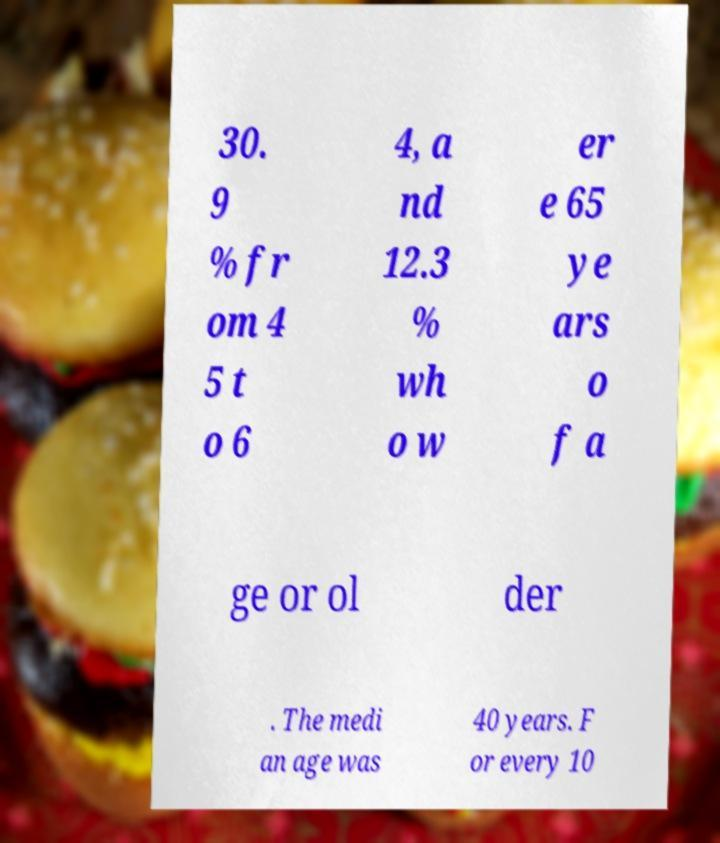What messages or text are displayed in this image? I need them in a readable, typed format. 30. 9 % fr om 4 5 t o 6 4, a nd 12.3 % wh o w er e 65 ye ars o f a ge or ol der . The medi an age was 40 years. F or every 10 